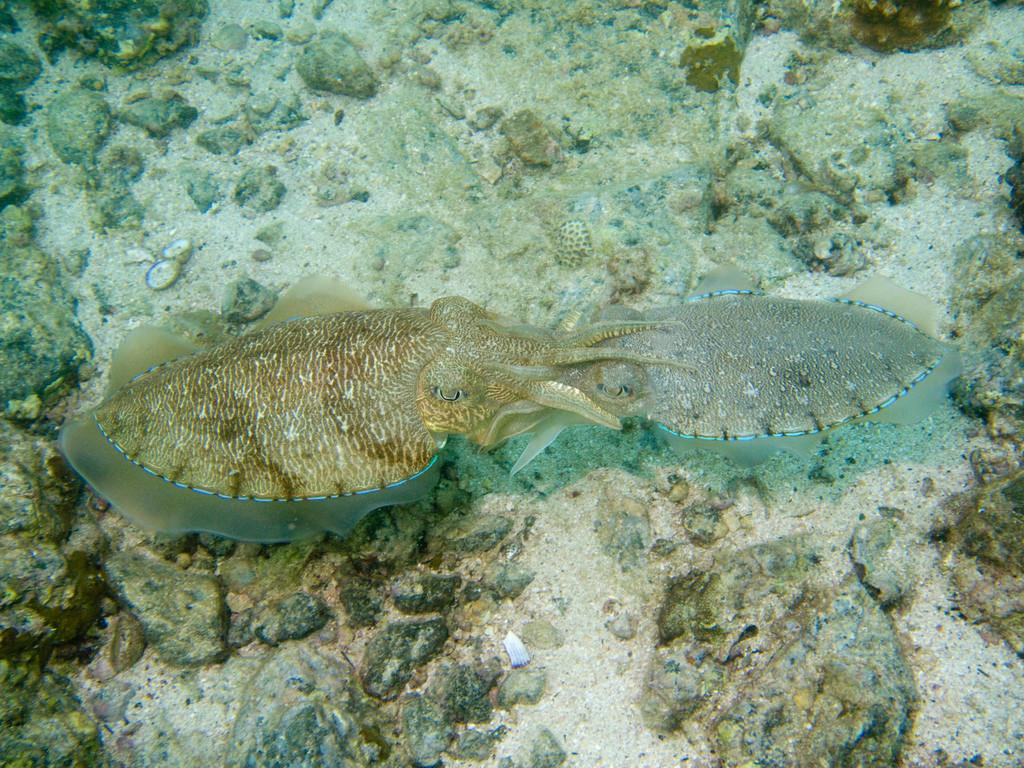What type of animals are in the image? There are two aquatic animals in the image. Where are the aquatic animals located? The aquatic animals are in water. What else can be seen in the image besides the aquatic animals? There are rocks visible in the image. How many chairs are present in the image? There are no chairs present in the image. What type of cake is being served in the image? There is no cake present in the image. 